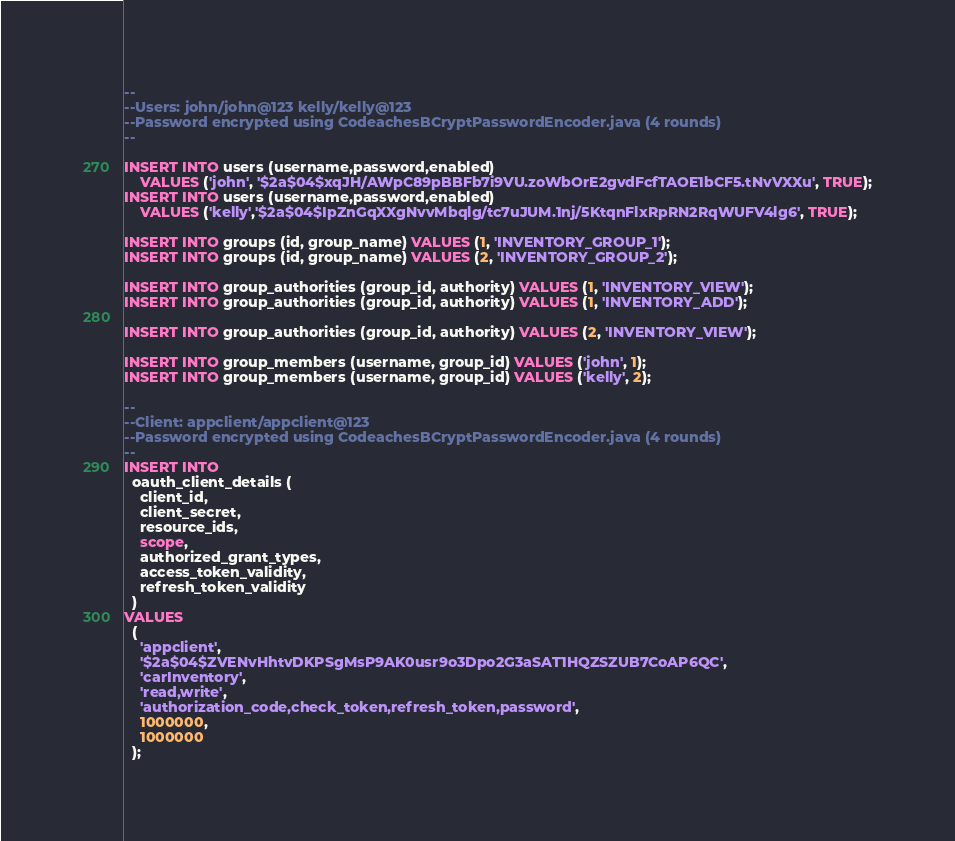<code> <loc_0><loc_0><loc_500><loc_500><_SQL_>--
--Users: john/john@123 kelly/kelly@123
--Password encrypted using CodeachesBCryptPasswordEncoder.java (4 rounds)
--

INSERT INTO users (username,password,enabled) 
    VALUES ('john', '$2a$04$xqJH/AWpC89pBBFb7i9VU.zoWbOrE2gvdFcfTAOE1bCF5.tNvVXXu', TRUE);
INSERT INTO users (username,password,enabled) 
    VALUES ('kelly','$2a$04$IpZnGqXXgNvvMbqlg/tc7uJUM.1nj/5KtqnFlxRpRN2RqWUFV4lg6', TRUE);

INSERT INTO groups (id, group_name) VALUES (1, 'INVENTORY_GROUP_1');
INSERT INTO groups (id, group_name) VALUES (2, 'INVENTORY_GROUP_2');

INSERT INTO group_authorities (group_id, authority) VALUES (1, 'INVENTORY_VIEW');
INSERT INTO group_authorities (group_id, authority) VALUES (1, 'INVENTORY_ADD');

INSERT INTO group_authorities (group_id, authority) VALUES (2, 'INVENTORY_VIEW');

INSERT INTO group_members (username, group_id) VALUES ('john', 1);
INSERT INTO group_members (username, group_id) VALUES ('kelly', 2);

--
--Client: appclient/appclient@123
--Password encrypted using CodeachesBCryptPasswordEncoder.java (4 rounds)
--
INSERT INTO
  oauth_client_details (
    client_id,
    client_secret,
    resource_ids,
    scope,
    authorized_grant_types,
    access_token_validity,
    refresh_token_validity
  )
VALUES
  (
    'appclient',
    '$2a$04$ZVENvHhtvDKPSgMsP9AK0usr9o3Dpo2G3aSAT1HQZSZUB7CoAP6QC',
    'carInventory',
    'read,write',
    'authorization_code,check_token,refresh_token,password',
    1000000,
    1000000
  );
</code> 